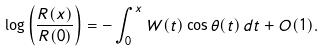<formula> <loc_0><loc_0><loc_500><loc_500>\log \left ( \frac { R ( x ) } { R ( 0 ) } \right ) = - \int _ { 0 } ^ { x } W ( t ) \cos \theta ( t ) \, d t + O ( 1 ) .</formula> 